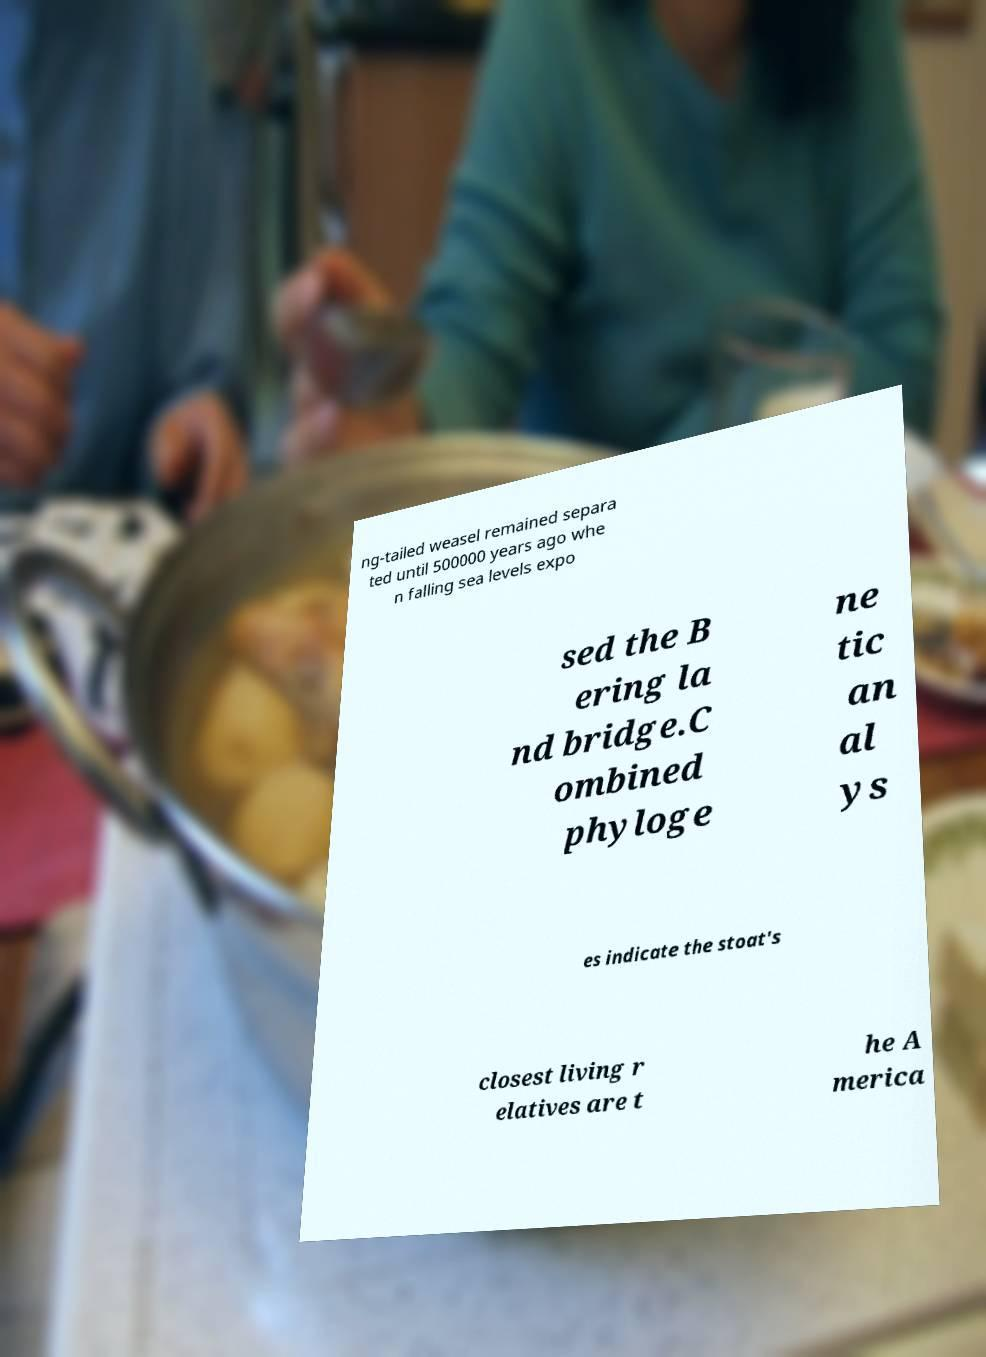Could you assist in decoding the text presented in this image and type it out clearly? ng-tailed weasel remained separa ted until 500000 years ago whe n falling sea levels expo sed the B ering la nd bridge.C ombined phyloge ne tic an al ys es indicate the stoat's closest living r elatives are t he A merica 